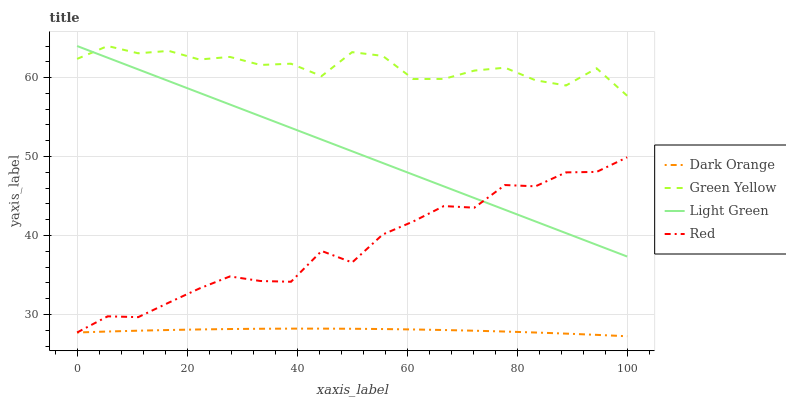Does Dark Orange have the minimum area under the curve?
Answer yes or no. Yes. Does Green Yellow have the maximum area under the curve?
Answer yes or no. Yes. Does Red have the minimum area under the curve?
Answer yes or no. No. Does Red have the maximum area under the curve?
Answer yes or no. No. Is Light Green the smoothest?
Answer yes or no. Yes. Is Green Yellow the roughest?
Answer yes or no. Yes. Is Red the smoothest?
Answer yes or no. No. Is Red the roughest?
Answer yes or no. No. Does Red have the lowest value?
Answer yes or no. No. Does Light Green have the highest value?
Answer yes or no. Yes. Does Red have the highest value?
Answer yes or no. No. Is Dark Orange less than Light Green?
Answer yes or no. Yes. Is Light Green greater than Dark Orange?
Answer yes or no. Yes. Does Dark Orange intersect Red?
Answer yes or no. Yes. Is Dark Orange less than Red?
Answer yes or no. No. Is Dark Orange greater than Red?
Answer yes or no. No. Does Dark Orange intersect Light Green?
Answer yes or no. No. 